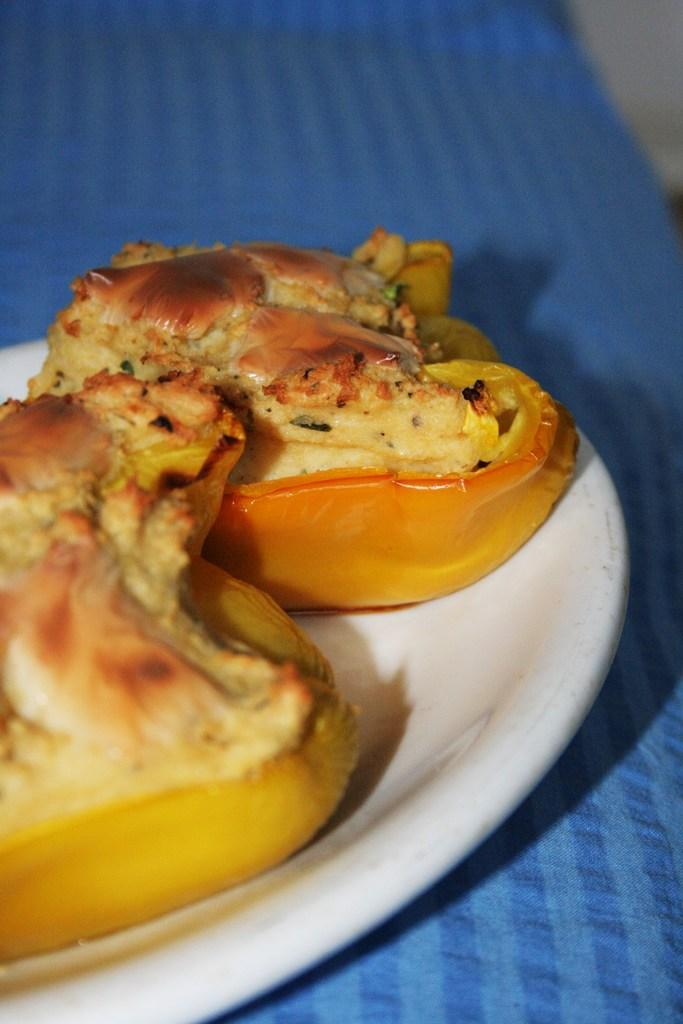What piece of furniture is present in the image? There is a table in the image. What is covering the table? There is a cloth on the table. What is placed on top of the cloth? There is a plate on the table. What can be found on the plate? There are food items on the plate. What type of beef is being served on the plate in the image? There is no beef present in the image; only a plate with food items is visible. Can you see any squirrels interacting with the food on the plate? There are no squirrels present in the image; it only features a table, cloth, plate, and food items. 